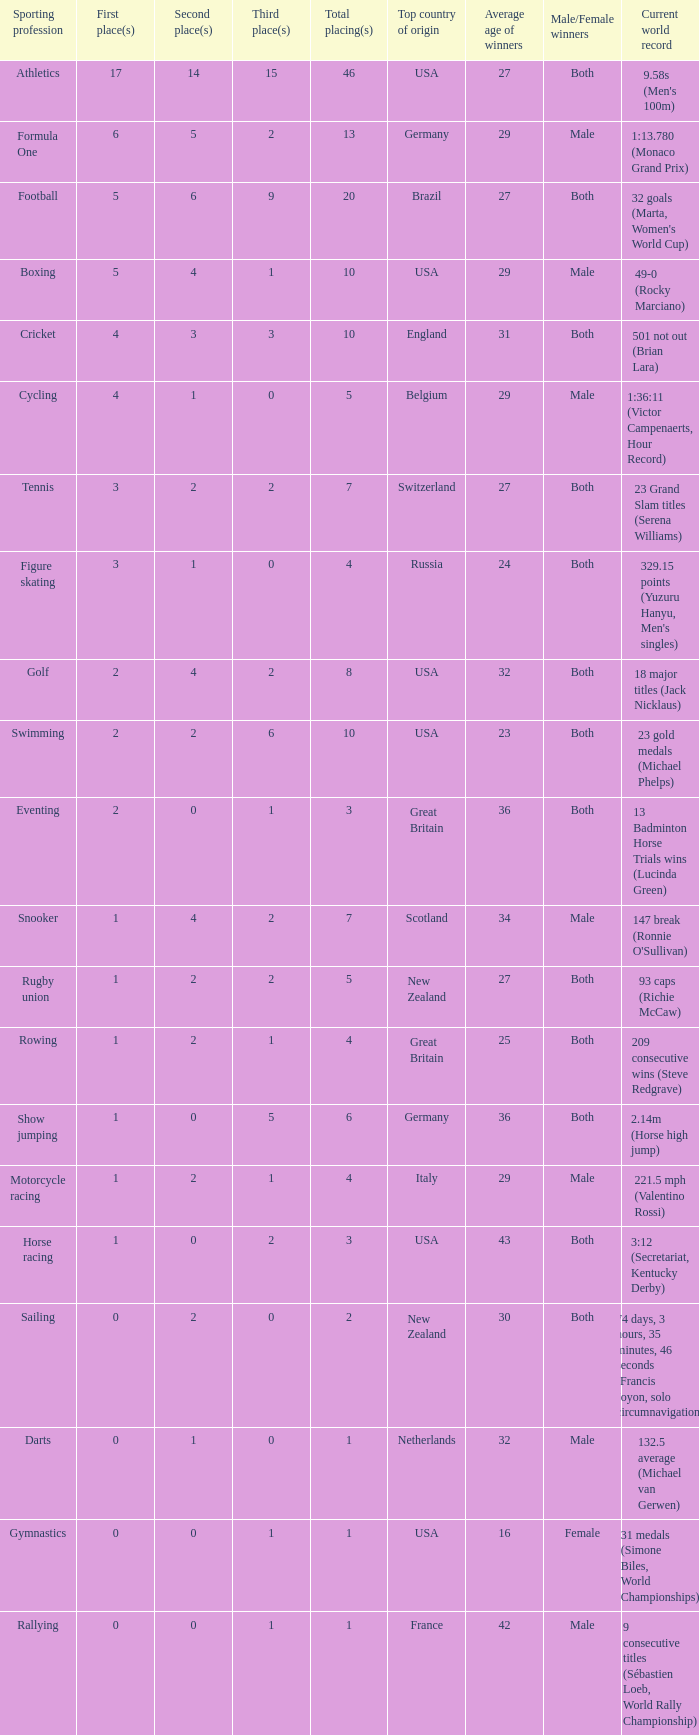What is the total number of 3rd place entries that have exactly 8 total placings? 1.0. 